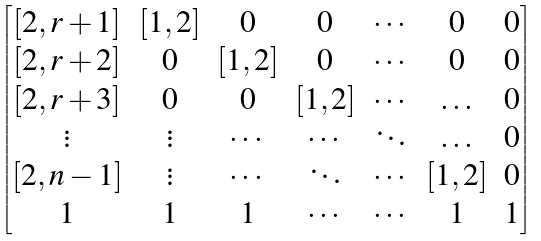<formula> <loc_0><loc_0><loc_500><loc_500>\begin{bmatrix} [ 2 , r + 1 ] & [ 1 , 2 ] & 0 & 0 & \cdots & 0 & 0 \\ [ 2 , r + 2 ] & 0 & [ 1 , 2 ] & 0 & \cdots & 0 & 0 \\ [ 2 , r + 3 ] & 0 & 0 & [ 1 , 2 ] & \cdots & \hdots & 0 \\ \vdots & \vdots & \cdots & \cdots & \ddots & \hdots & 0 \\ [ 2 , n - 1 ] & \vdots & \cdots & \ddots & \cdots & [ 1 , 2 ] & 0 \\ 1 & 1 & 1 & \cdots & \cdots & 1 & 1 \\ \end{bmatrix}</formula> 